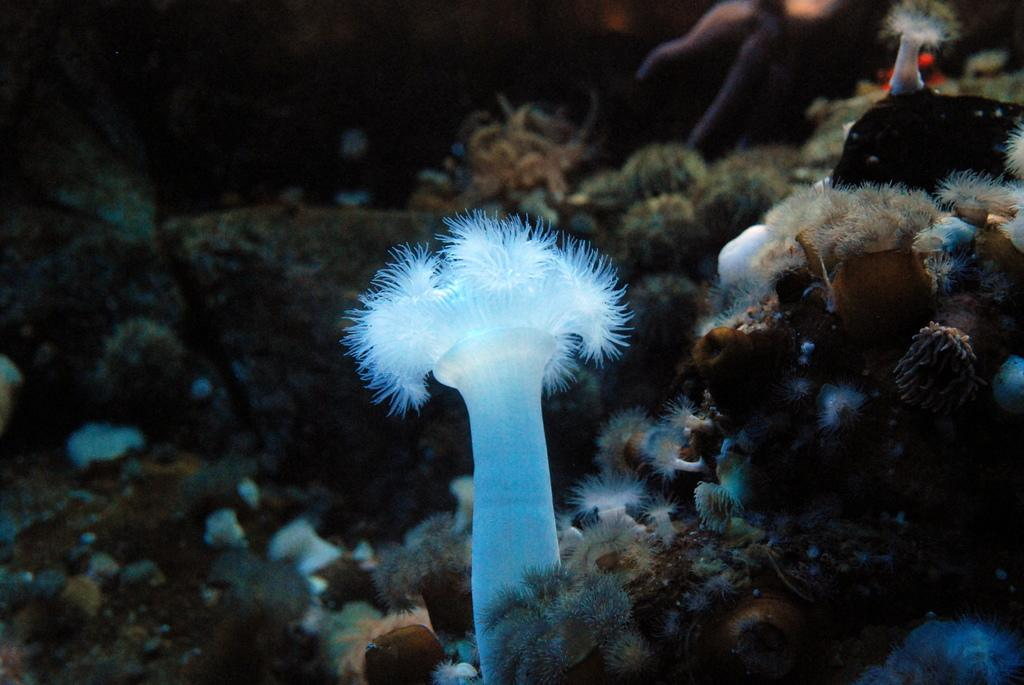What type of plants are present in the image? There are aquatic plants in the image. Can you describe the background of the image? There are stones visible in the background of the image. What type of church is depicted in the image? There is no church present in the image; it features aquatic plants and stones. What type of collar is visible on the person in the image? There is no person or collar present in the image. 